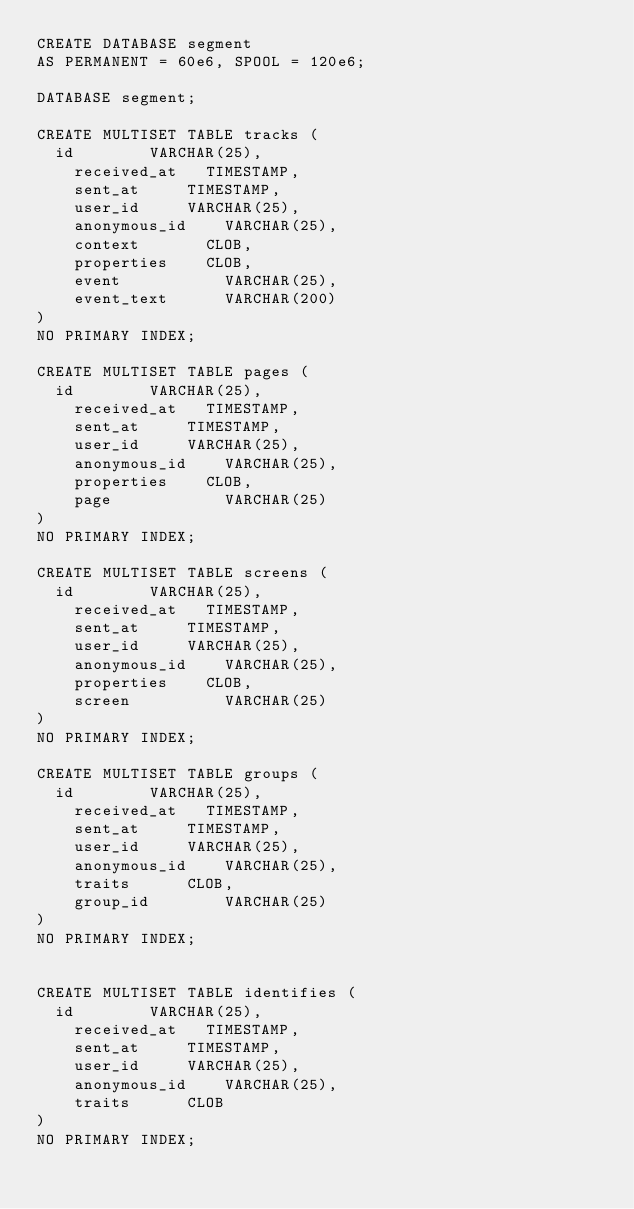<code> <loc_0><loc_0><loc_500><loc_500><_SQL_>CREATE DATABASE segment
AS PERMANENT = 60e6, SPOOL = 120e6;

DATABASE segment;

CREATE MULTISET TABLE tracks (
  id				VARCHAR(25),
    received_at		TIMESTAMP,
    sent_at			TIMESTAMP,
    user_id			VARCHAR(25),
    anonymous_id    VARCHAR(25),
    context   		CLOB,
    properties 		CLOB,
    event           VARCHAR(25),
    event_text      VARCHAR(200)
)
NO PRIMARY INDEX;

CREATE MULTISET TABLE pages (
  id				VARCHAR(25),
    received_at		TIMESTAMP,
    sent_at			TIMESTAMP,
    user_id			VARCHAR(25),
    anonymous_id    VARCHAR(25),
    properties 		CLOB,
    page           	VARCHAR(25)
)
NO PRIMARY INDEX;

CREATE MULTISET TABLE screens (
  id				VARCHAR(25),
    received_at		TIMESTAMP,
    sent_at			TIMESTAMP,
    user_id			VARCHAR(25),
    anonymous_id    VARCHAR(25),
    properties 		CLOB,
    screen          VARCHAR(25)
)
NO PRIMARY INDEX;

CREATE MULTISET TABLE groups (
  id				VARCHAR(25),
    received_at		TIMESTAMP,
    sent_at			TIMESTAMP,
    user_id			VARCHAR(25),
    anonymous_id    VARCHAR(25),
    traits 			CLOB,
    group_id        VARCHAR(25)
)
NO PRIMARY INDEX;


CREATE MULTISET TABLE identifies (
  id				VARCHAR(25),
    received_at		TIMESTAMP,
    sent_at			TIMESTAMP,
    user_id			VARCHAR(25),
    anonymous_id    VARCHAR(25),
    traits 			CLOB
)
NO PRIMARY INDEX;
</code> 